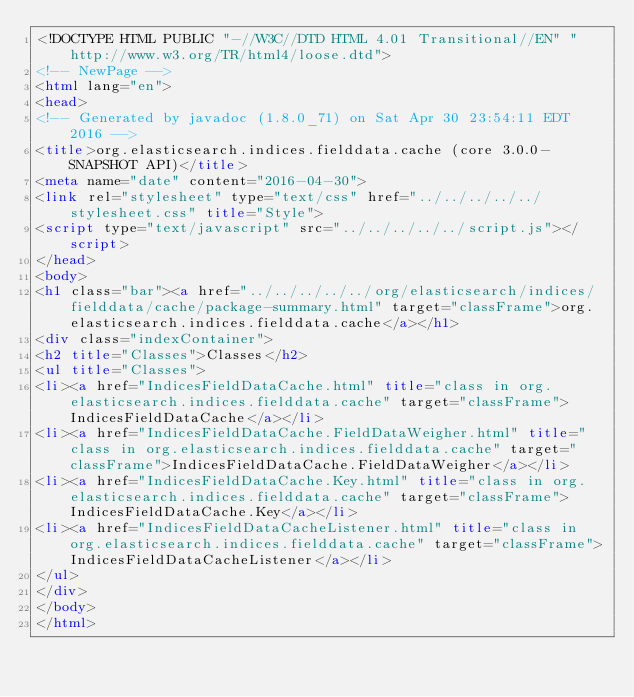Convert code to text. <code><loc_0><loc_0><loc_500><loc_500><_HTML_><!DOCTYPE HTML PUBLIC "-//W3C//DTD HTML 4.01 Transitional//EN" "http://www.w3.org/TR/html4/loose.dtd">
<!-- NewPage -->
<html lang="en">
<head>
<!-- Generated by javadoc (1.8.0_71) on Sat Apr 30 23:54:11 EDT 2016 -->
<title>org.elasticsearch.indices.fielddata.cache (core 3.0.0-SNAPSHOT API)</title>
<meta name="date" content="2016-04-30">
<link rel="stylesheet" type="text/css" href="../../../../../stylesheet.css" title="Style">
<script type="text/javascript" src="../../../../../script.js"></script>
</head>
<body>
<h1 class="bar"><a href="../../../../../org/elasticsearch/indices/fielddata/cache/package-summary.html" target="classFrame">org.elasticsearch.indices.fielddata.cache</a></h1>
<div class="indexContainer">
<h2 title="Classes">Classes</h2>
<ul title="Classes">
<li><a href="IndicesFieldDataCache.html" title="class in org.elasticsearch.indices.fielddata.cache" target="classFrame">IndicesFieldDataCache</a></li>
<li><a href="IndicesFieldDataCache.FieldDataWeigher.html" title="class in org.elasticsearch.indices.fielddata.cache" target="classFrame">IndicesFieldDataCache.FieldDataWeigher</a></li>
<li><a href="IndicesFieldDataCache.Key.html" title="class in org.elasticsearch.indices.fielddata.cache" target="classFrame">IndicesFieldDataCache.Key</a></li>
<li><a href="IndicesFieldDataCacheListener.html" title="class in org.elasticsearch.indices.fielddata.cache" target="classFrame">IndicesFieldDataCacheListener</a></li>
</ul>
</div>
</body>
</html>
</code> 